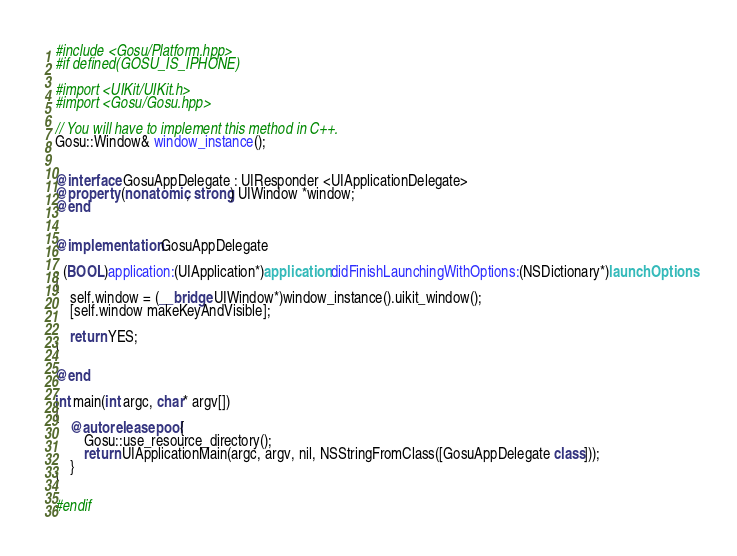Convert code to text. <code><loc_0><loc_0><loc_500><loc_500><_ObjectiveC_>#include <Gosu/Platform.hpp>
#if defined(GOSU_IS_IPHONE)

#import <UIKit/UIKit.h>
#import <Gosu/Gosu.hpp>

// You will have to implement this method in C++.
Gosu::Window& window_instance();


@interface GosuAppDelegate : UIResponder <UIApplicationDelegate>
@property (nonatomic, strong) UIWindow *window;
@end


@implementation GosuAppDelegate

- (BOOL)application:(UIApplication*)application didFinishLaunchingWithOptions:(NSDictionary*)launchOptions
{
    self.window = (__bridge UIWindow*)window_instance().uikit_window();
    [self.window makeKeyAndVisible];
    
    return YES;
}

@end

int main(int argc, char* argv[])
{
    @autoreleasepool {
        Gosu::use_resource_directory();
        return UIApplicationMain(argc, argv, nil, NSStringFromClass([GosuAppDelegate class]));
    }
}

#endif
</code> 